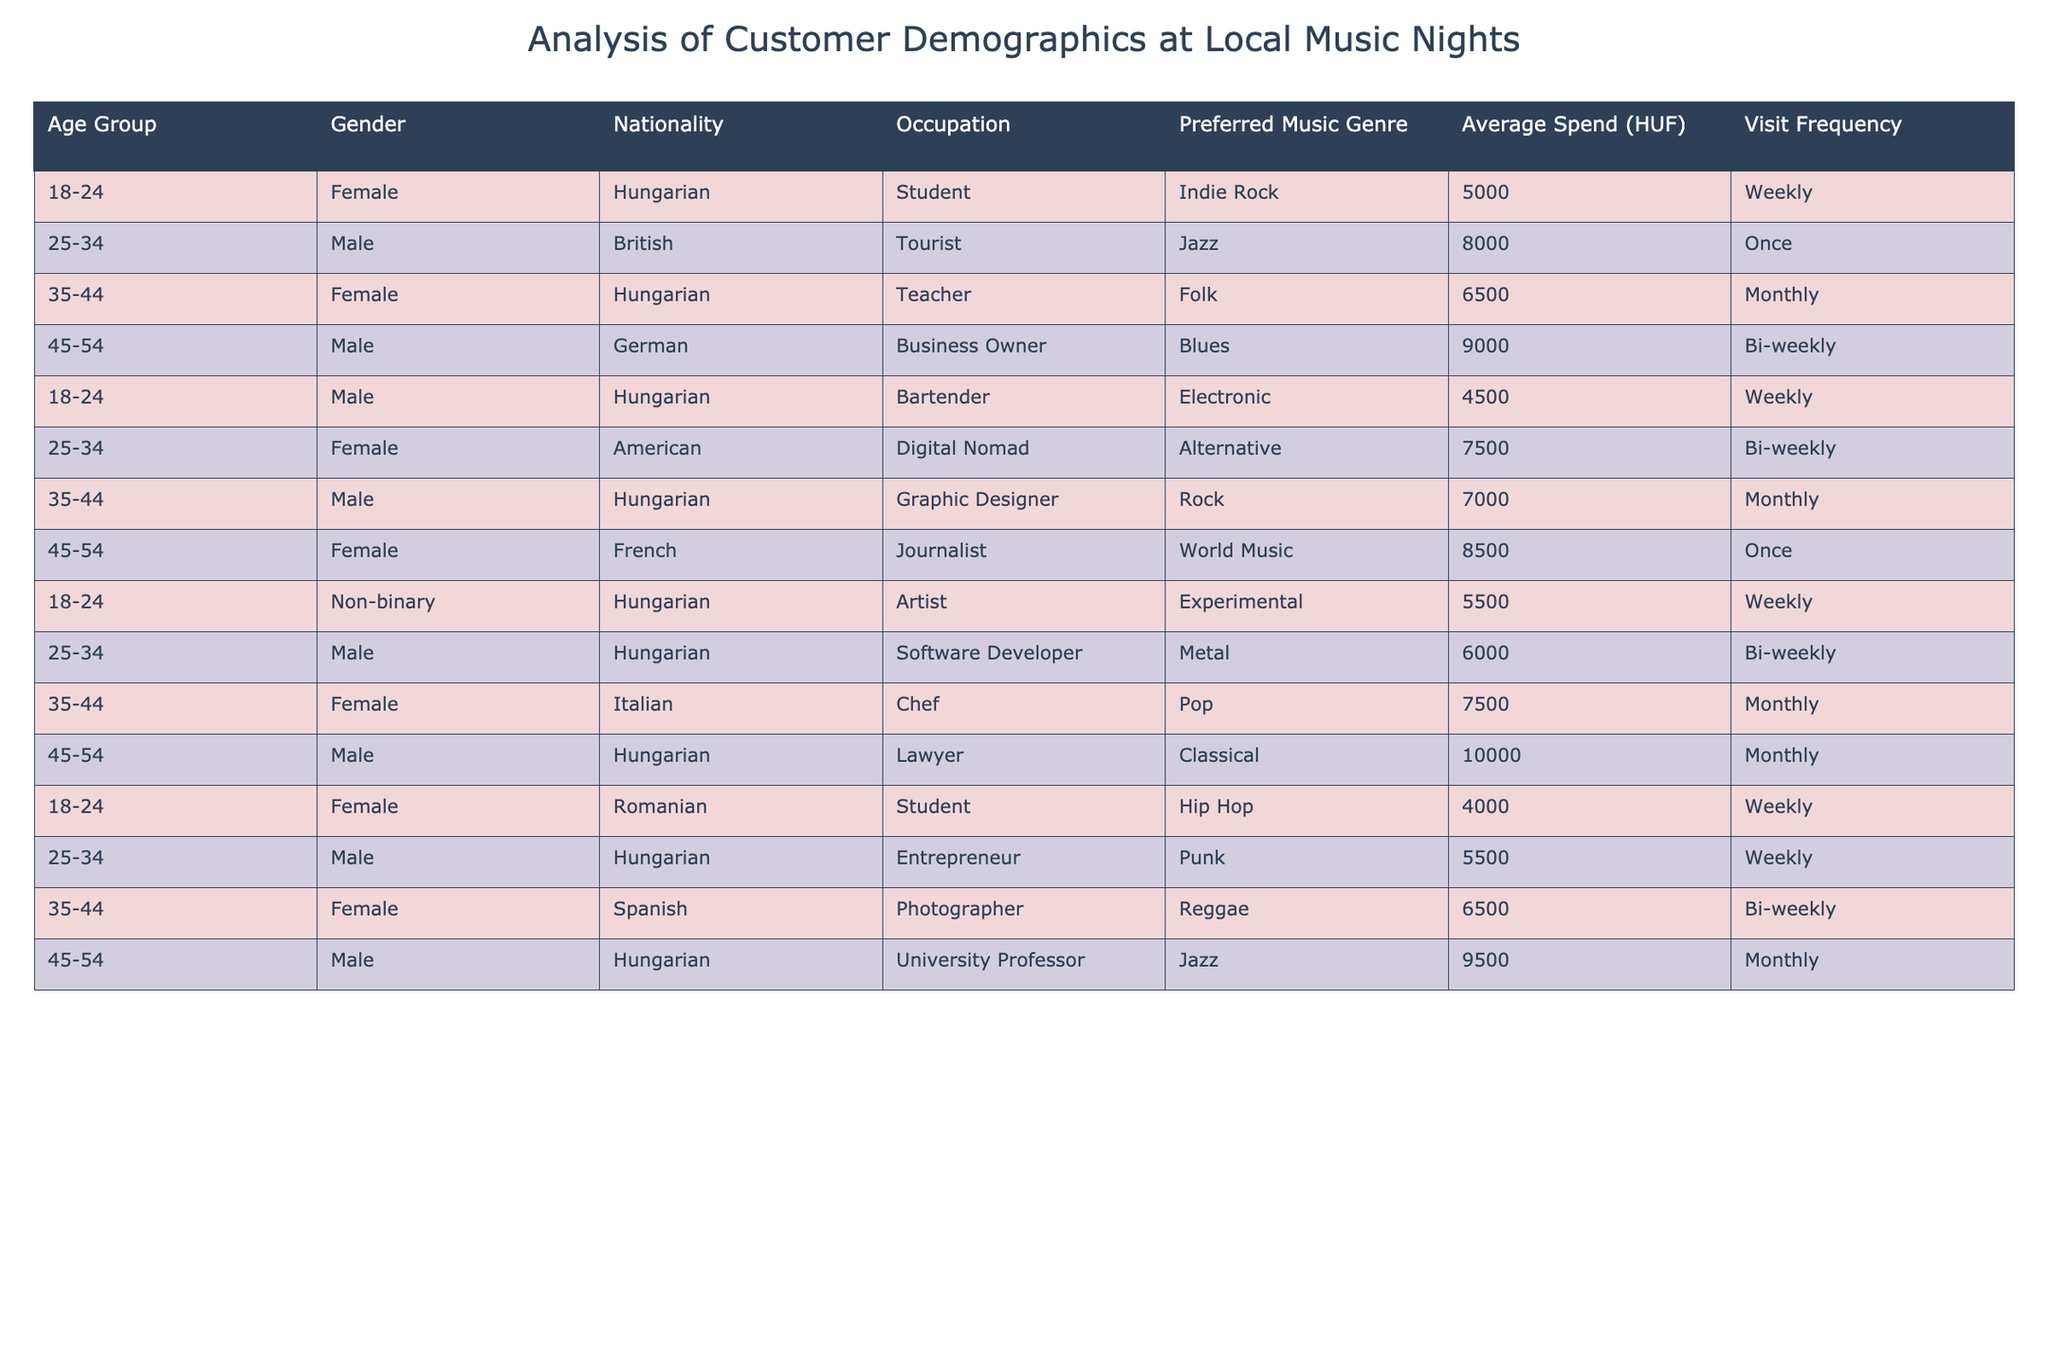What is the Preferred Music Genre for the youngest age group? The youngest age group (18-24) has several entries in the table. The genres listed are Indie Rock, Electronic, Experimental, and Hip Hop. Therefore, there isn't a single preferred genre but multiple interests.
Answer: Multiple genres What is the average spend for Female attendees? To find the average spend for Female attendees, I will sum all values under the "Average Spend (HUF)" column for Females. The total is 5,000 + 6,500 + 8,500 + 7,500 = 27,500 HUF, and there are 4 data points. Thus, the average is 27,500 / 4 = 6,875 HUF.
Answer: 6875 HUF Do more customers prefer Jazz or Blues? There are 3 entries for Jazz (with spends of 8,000, 9,500) and 1 entry for Blues (with a spend of 9,000). Since there are more entries for Jazz, it suggests a greater preference for Jazz over Blues.
Answer: Jazz preferred What is the most common Visit Frequency among the attendees? The visit frequencies listed are Weekly, Monthly, Bi-weekly, and Once. Counting the occurrences: Weekly appears 6 times, Monthly 4 times, Bi-weekly 4 times, and Once 3 times. Thus, Weekly is the most common frequency.
Answer: Weekly Which age group has the highest average spend? The average spends for each age group are: 18-24: (5,000 + 4,500 + 5,500 + 4,000) / 4 = 4,750 HUF; 25-34: (8,000 + 7,500 + 6,000 + 5,500) / 4 = 6,750 HUF; 35-44: (6,500 + 7,000 + 7,500 + 9,500) / 4 = 7,625 HUF; 45-54: (9,000 + 8,500 + 10,000 + 9,500) / 4 = 9,250 HUF. The highest is in the 45-54 age group with 9,250 HUF.
Answer: 45-54 age group Are there any Non-binary attendees in the list? Upon checking the "Gender" column, there is one entry for Non-binary in the age group 18-24. Therefore, yes, there are Non-binary attendees.
Answer: Yes What is the total average spend of tourists? There is one entry for a Tourist in the age group 25-34 with an average spend of 8,000 HUF. As there is only one data point, the total average spend for tourists is 8,000 HUF.
Answer: 8000 HUF How many attendees belong to the 35-44 age group? Counting the entries for the 35-44 age group, there are 4 data points. Thus, the total number of attendees in this age group is 4.
Answer: 4 What is the gender representation in terms of frequency (how many males and females)? Looking at the entries: Males: 6, Females: 6, Non-binary: 1. Thus, the gender representation is equal for males and females with 6 each and 1 non-binary.
Answer: 6 males, 6 females, 1 non-binary Is the average spend for Digital Nomads higher than the average for Students? The average spend for Digital Nomads is 7,500 HUF, and for Students (two entries) it is (5,000 + 4,000) / 2 = 4,500 HUF. Since 7,500 HUF > 4,500 HUF, Digital Nomads do have a higher average spend than Students.
Answer: Yes What is the total frequency of visits for musicians attending the events? By analyzing the entries for occupations related to musicians (Artist, Bartender), both have a Weekly visit frequency. Therefore, there are 2 frequencies listed for musicians, which is weekly.
Answer: Weekly, 2 entries 